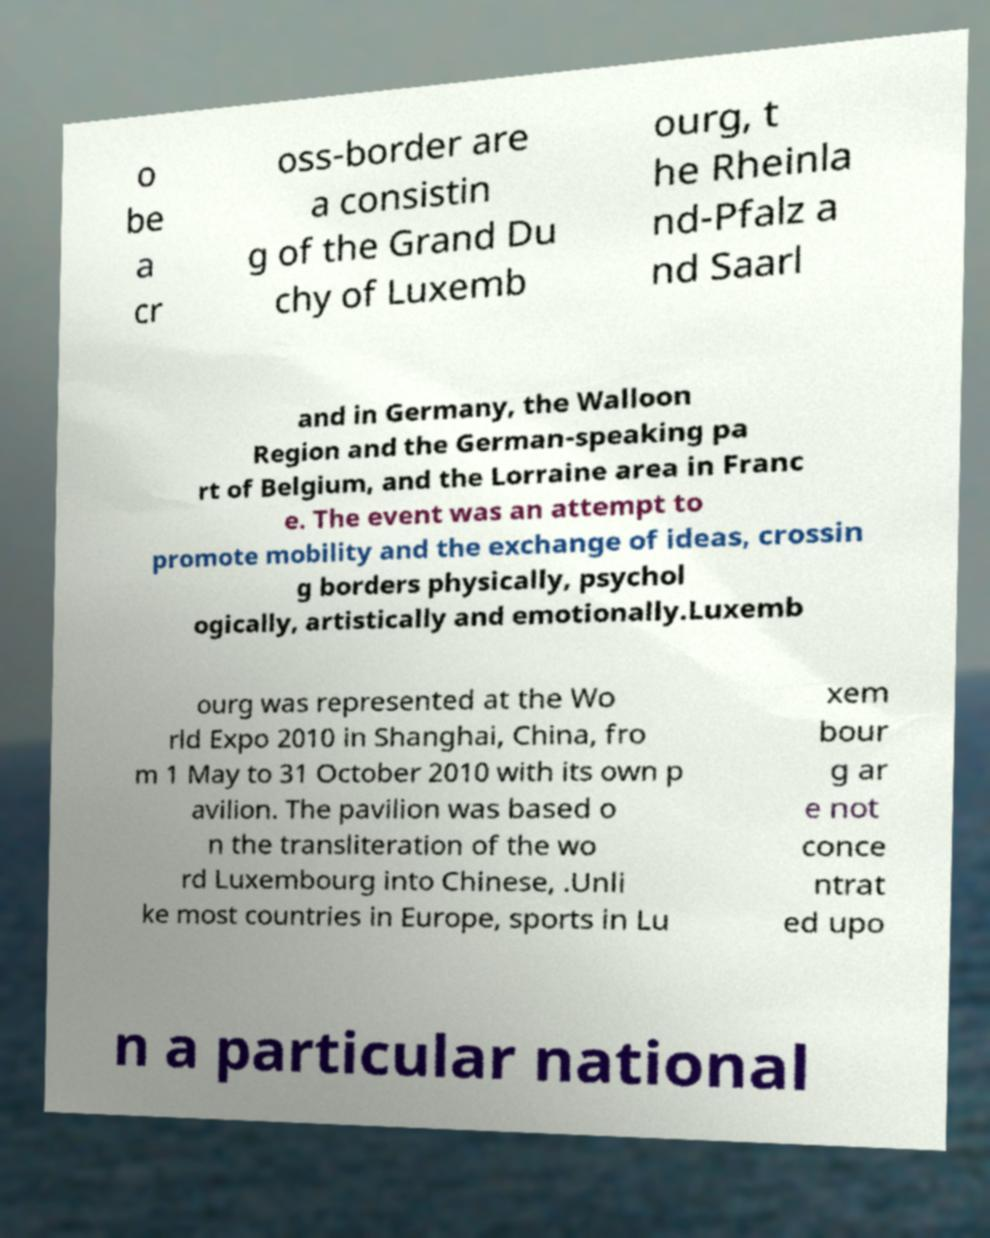What messages or text are displayed in this image? I need them in a readable, typed format. o be a cr oss-border are a consistin g of the Grand Du chy of Luxemb ourg, t he Rheinla nd-Pfalz a nd Saarl and in Germany, the Walloon Region and the German-speaking pa rt of Belgium, and the Lorraine area in Franc e. The event was an attempt to promote mobility and the exchange of ideas, crossin g borders physically, psychol ogically, artistically and emotionally.Luxemb ourg was represented at the Wo rld Expo 2010 in Shanghai, China, fro m 1 May to 31 October 2010 with its own p avilion. The pavilion was based o n the transliteration of the wo rd Luxembourg into Chinese, .Unli ke most countries in Europe, sports in Lu xem bour g ar e not conce ntrat ed upo n a particular national 